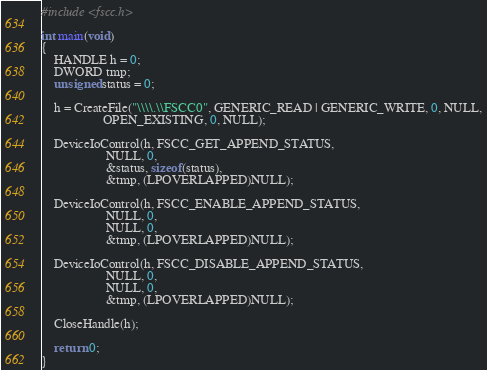Convert code to text. <code><loc_0><loc_0><loc_500><loc_500><_C_>#include <fscc.h>

int main(void)
{
    HANDLE h = 0;
    DWORD tmp;
    unsigned status = 0;

    h = CreateFile("\\\\.\\FSCC0", GENERIC_READ | GENERIC_WRITE, 0, NULL,
                   OPEN_EXISTING, 0, NULL);

    DeviceIoControl(h, FSCC_GET_APPEND_STATUS,
                    NULL, 0,
                    &status, sizeof(status),
                    &tmp, (LPOVERLAPPED)NULL);

    DeviceIoControl(h, FSCC_ENABLE_APPEND_STATUS,
                    NULL, 0,
                    NULL, 0,
                    &tmp, (LPOVERLAPPED)NULL);

    DeviceIoControl(h, FSCC_DISABLE_APPEND_STATUS,
                    NULL, 0,
                    NULL, 0,
                    &tmp, (LPOVERLAPPED)NULL);

    CloseHandle(h);

    return 0;
}</code> 